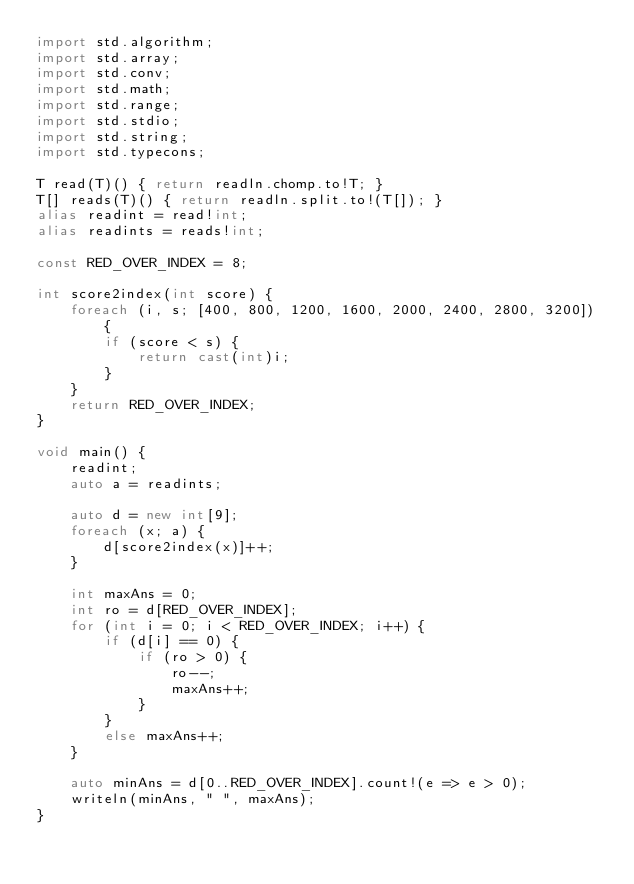Convert code to text. <code><loc_0><loc_0><loc_500><loc_500><_D_>import std.algorithm;
import std.array;
import std.conv;
import std.math;
import std.range;
import std.stdio;
import std.string;
import std.typecons;

T read(T)() { return readln.chomp.to!T; }
T[] reads(T)() { return readln.split.to!(T[]); }
alias readint = read!int;
alias readints = reads!int;

const RED_OVER_INDEX = 8;

int score2index(int score) {
    foreach (i, s; [400, 800, 1200, 1600, 2000, 2400, 2800, 3200]) {
        if (score < s) {
            return cast(int)i;
        }
    }
    return RED_OVER_INDEX;
}

void main() {
    readint;
    auto a = readints;

    auto d = new int[9];
    foreach (x; a) {
        d[score2index(x)]++;
    }

    int maxAns = 0;
    int ro = d[RED_OVER_INDEX];
    for (int i = 0; i < RED_OVER_INDEX; i++) {
        if (d[i] == 0) {
            if (ro > 0) {
                ro--;
                maxAns++;
            }
        }
        else maxAns++;
    }

    auto minAns = d[0..RED_OVER_INDEX].count!(e => e > 0);
    writeln(minAns, " ", maxAns);
}
</code> 